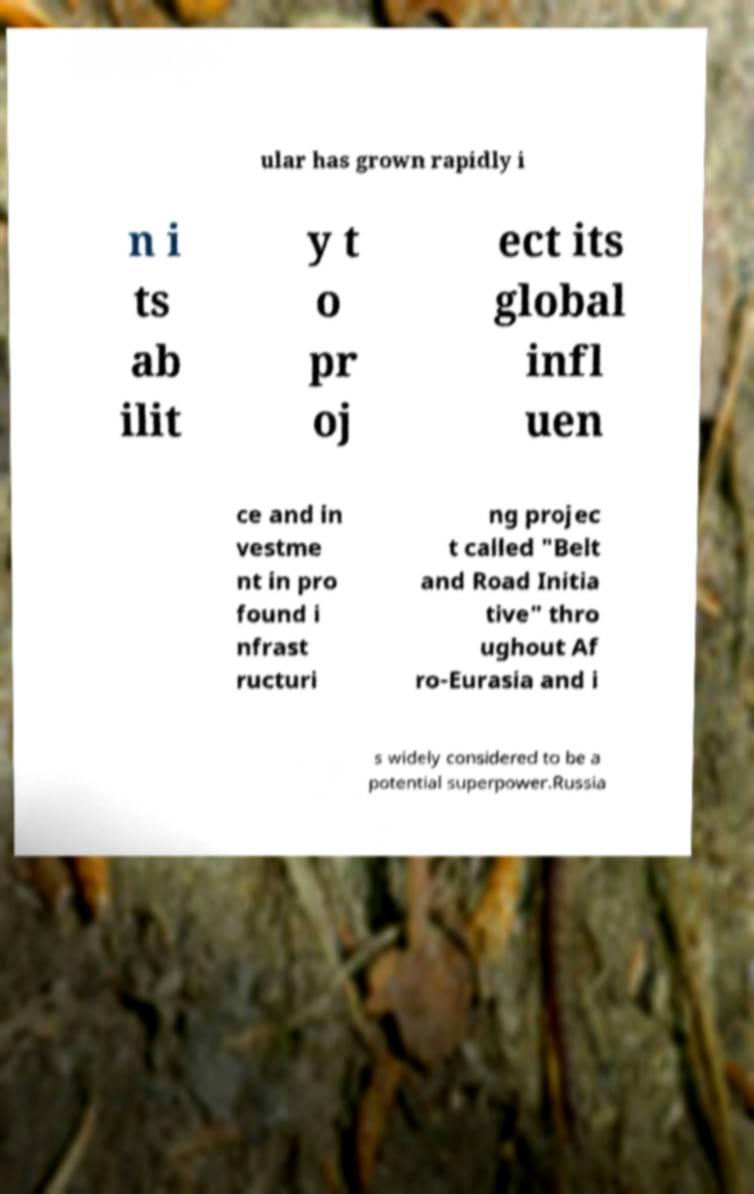What messages or text are displayed in this image? I need them in a readable, typed format. ular has grown rapidly i n i ts ab ilit y t o pr oj ect its global infl uen ce and in vestme nt in pro found i nfrast ructuri ng projec t called "Belt and Road Initia tive" thro ughout Af ro-Eurasia and i s widely considered to be a potential superpower.Russia 